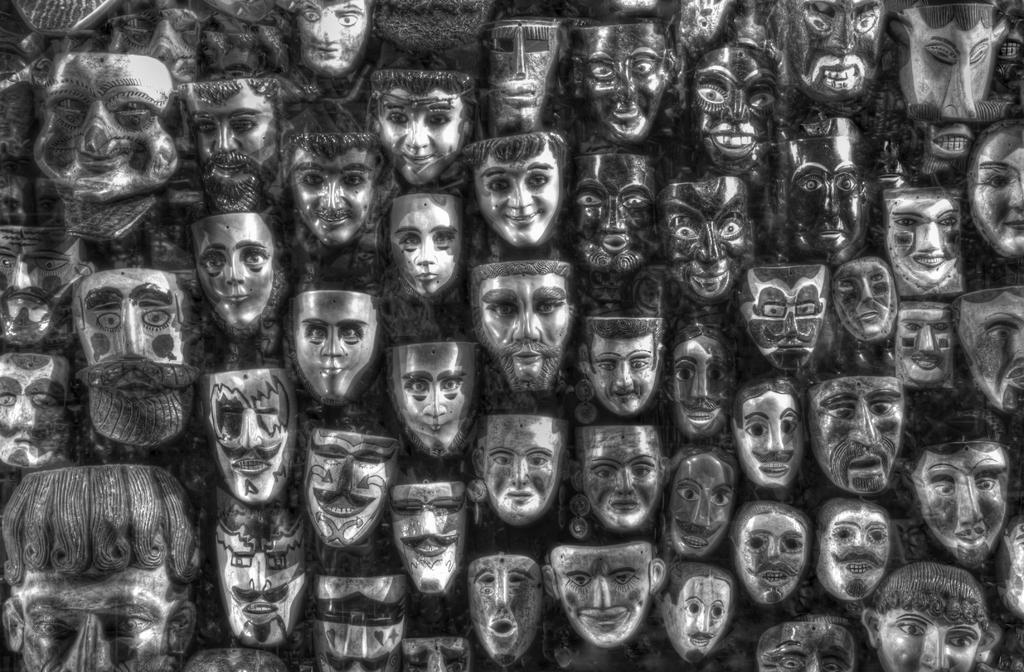In one or two sentences, can you explain what this image depicts? In this image, we can see face masks throughout the image. 